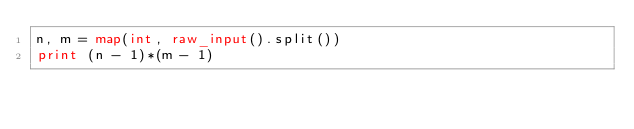<code> <loc_0><loc_0><loc_500><loc_500><_Python_>n, m = map(int, raw_input().split())
print (n - 1)*(m - 1)
</code> 